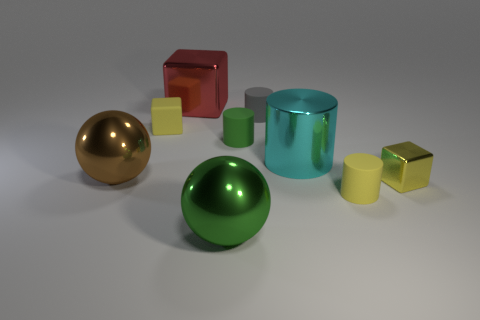The small matte object that is the same color as the tiny rubber block is what shape?
Give a very brief answer. Cylinder. How many tiny objects are matte cubes or yellow objects?
Your answer should be very brief. 3. How many other tiny gray matte things are the same shape as the small gray object?
Offer a terse response. 0. The ball that is behind the large shiny ball to the right of the big brown thing is made of what material?
Your response must be concise. Metal. There is a matte thing that is behind the small yellow rubber block; what is its size?
Offer a terse response. Small. How many yellow objects are large rubber objects or tiny blocks?
Keep it short and to the point. 2. Are there any other things that have the same material as the tiny yellow cylinder?
Provide a succinct answer. Yes. What material is the other large thing that is the same shape as the large green shiny thing?
Make the answer very short. Metal. Is the number of large red blocks that are in front of the gray rubber cylinder the same as the number of tiny blue shiny cylinders?
Offer a very short reply. Yes. What is the size of the object that is right of the gray rubber thing and in front of the small shiny thing?
Offer a terse response. Small. 